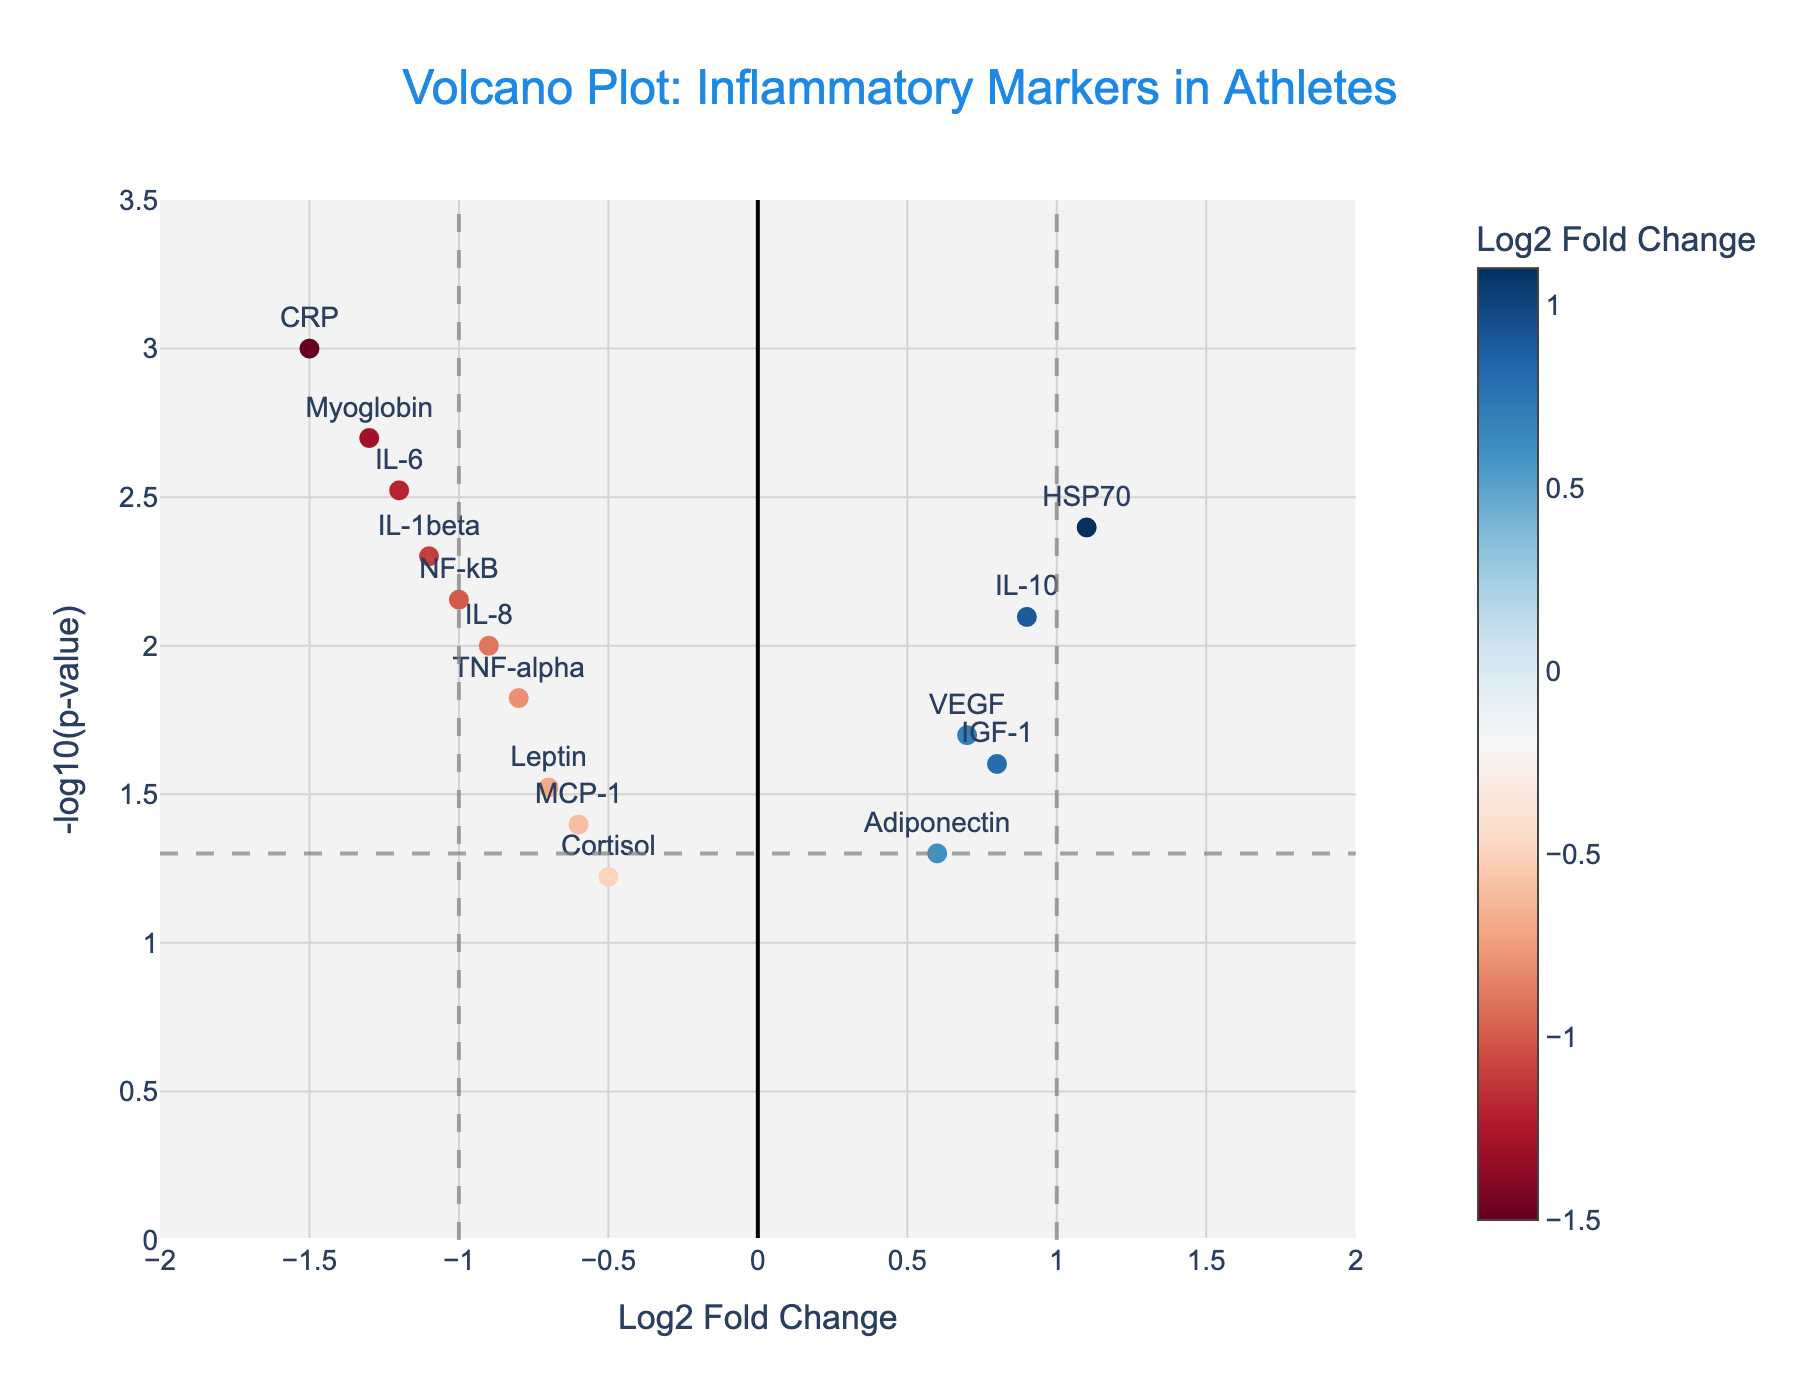What is the title of the figure? The title of the figure can be found at the top of the plot, which provides a brief description of what the data visualization represents. It reads "Volcano Plot: Inflammatory Markers in Athletes."
Answer: Volcano Plot: Inflammatory Markers in Athletes How many different genes are represented in the plot? By counting the number of unique genes labeled in the plot, we can determine that there are 15 different genes represented.
Answer: 15 Which gene has the highest log2 fold change? From the plot, the gene HSP70 is located at 1.1 on the x-axis, indicating it has the highest log2 fold change.
Answer: HSP70 Which gene has the lowest p-value? From the plot, the gene with the highest -log10(p-value) on the y-axis represents the lowest p-value. Myoglobin is located at around 3.0 on the y-axis, indicating it has the lowest p-value.
Answer: Myoglobin Which genes have a log2 fold change greater than 1? By examining the x-axis for values greater than 1, we can find that HSP70 is the only gene with a log2 fold change greater than 1.
Answer: HSP70 Which genes have a p-value less than 0.01? For genes with a -log10(p-value) greater than 2 (since -log10(0.01) = 2), we see that IL-6, CRP, IL-1beta, Myoglobin, and NF-kB meet this criteria. These genes are placed above the horizontal line at y=2.
Answer: IL-6, CRP, IL-1beta, Myoglobin, NF-kB Which genes lie below the p-value threshold line but above the fold change threshold lines? This requires checking for genes that are above the horizontal line (indicating -log10(p-value) > -log10(0.05)) and within the range -1 < log2 fold change < 1. IL-10, VEGF, IGF-1, and IL-8 fit this description.
Answer: IL-10, VEGF, IGF-1, IL-8 How many genes have a negative log2 fold change and a p-value greater than 0.05? Genes with a negative log2 fold change to the left of the x-axis and a -log10(p-value) less than 1.3 should be counted. Cortisol is the only gene fitting these criteria.
Answer: 1 Compare the log2 fold change of IL-6 and IL-8. Which one is greater? IL-6 has a log2 fold change of -1.2 while IL-8 has a log2 fold change of -0.9. Comparing these, IL-8 has a higher log2 fold change than IL-6.
Answer: IL-8 is greater Identify genes that have a positive log2 fold change and are statistically significant (p-value < 0.05). Positive log2 fold change is represented by positive x-axis values and statistically significant is indicated by -log10(p-value) > 1.3. The genes fitting these criteria are IL-10, VEGF, IGF-1, and HSP70.
Answer: IL-10, VEGF, IGF-1, HSP70 